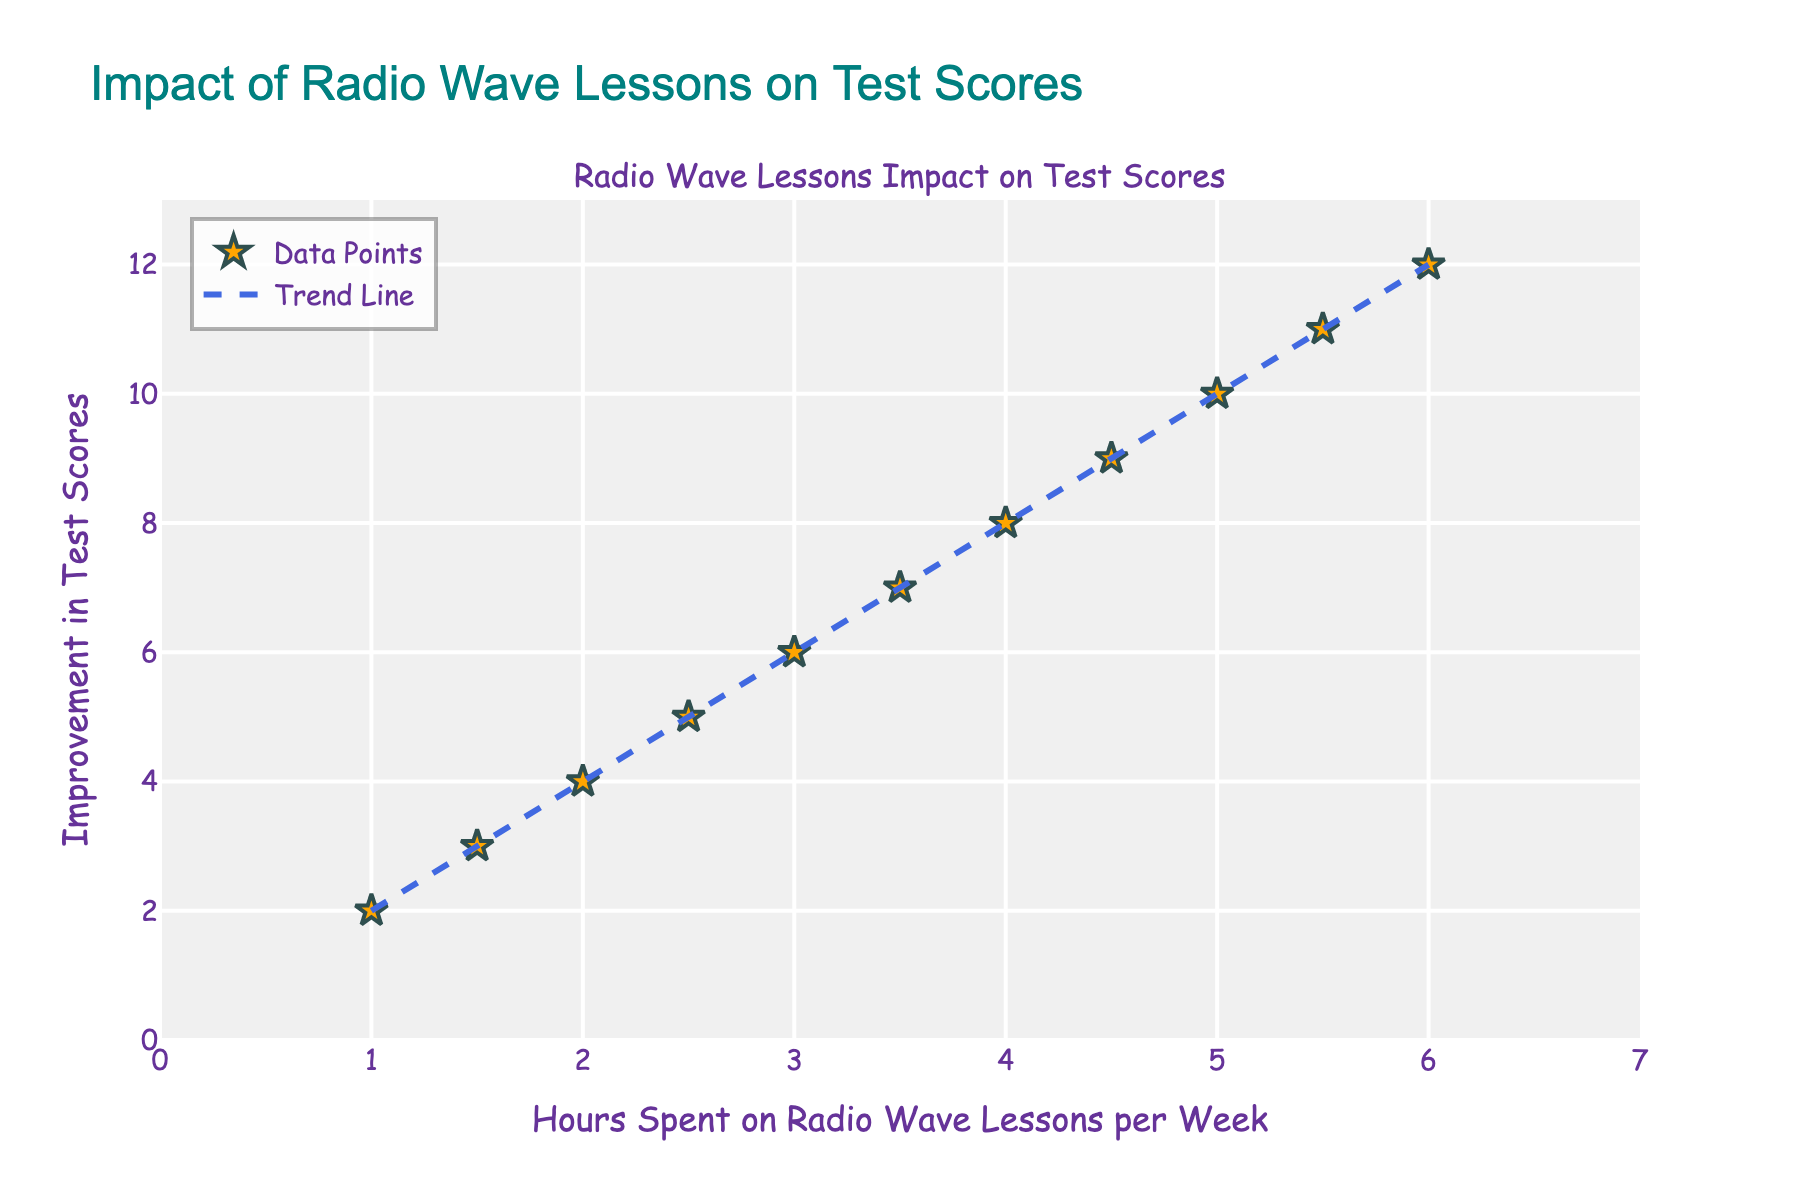What is the title of the plot? The title is prominently displayed at the top of the plot.
Answer: Impact of Radio Wave Lessons on Test Scores What are the variables represented on the x-axis and y-axis? The axes are labeled near the borders of the plot. The x-axis shows the independent variable while the y-axis shows the dependent variable.
Answer: Hours Spent on Radio Wave Lessons per Week (x-axis) and Improvement in Test Scores (y-axis) How many data points are present in the scatter plot? Data points are represented by star markers, and counting them gives the total number of data points.
Answer: 11 What color are the data points in the scatter plot? Data points have a distinct visual color represented in the plot legend or the markers themselves.
Answer: Orange What is the shape of the markers representing the data points? The markers can be identified by their shape on the plot.
Answer: Star Describe the trend line shown in the plot. The trend line is depicted as a dashed line that shows the general direction of the data. It is blue and runs diagonally from low to high values.
Answer: A dashed blue line running upwards What is the approximate slope of the trend line? The slope can be estimated by noting the rise over the run between two points on the trend line.
Answer: Approximately 2 If a student spends 2.5 hours on radio wave lessons per week, what is their expected improvement in test scores according to the trend line? Find the y-value on the trend line corresponding to x = 2.5.
Answer: About 5 Which data point shows the highest improvement in test scores? Identify the data point farthest up on the y-axis.
Answer: (6, 12) How does the data trend compare between 1 hour and 5 hours of radio wave lessons per week? Compare the improvement in test scores from the trend line at x = 1 and x = 5.
Answer: Improvement goes from approximately 2 to 10 